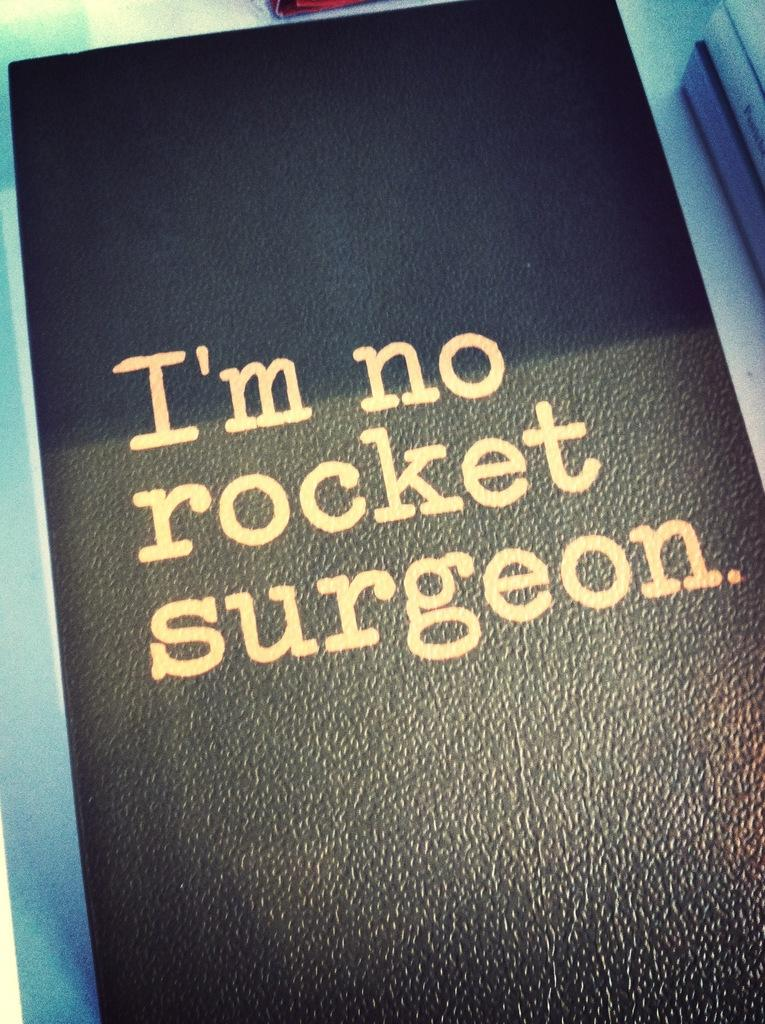Provide a one-sentence caption for the provided image. Looks like a diary with a title on it as I'm no rocket surgeon. 